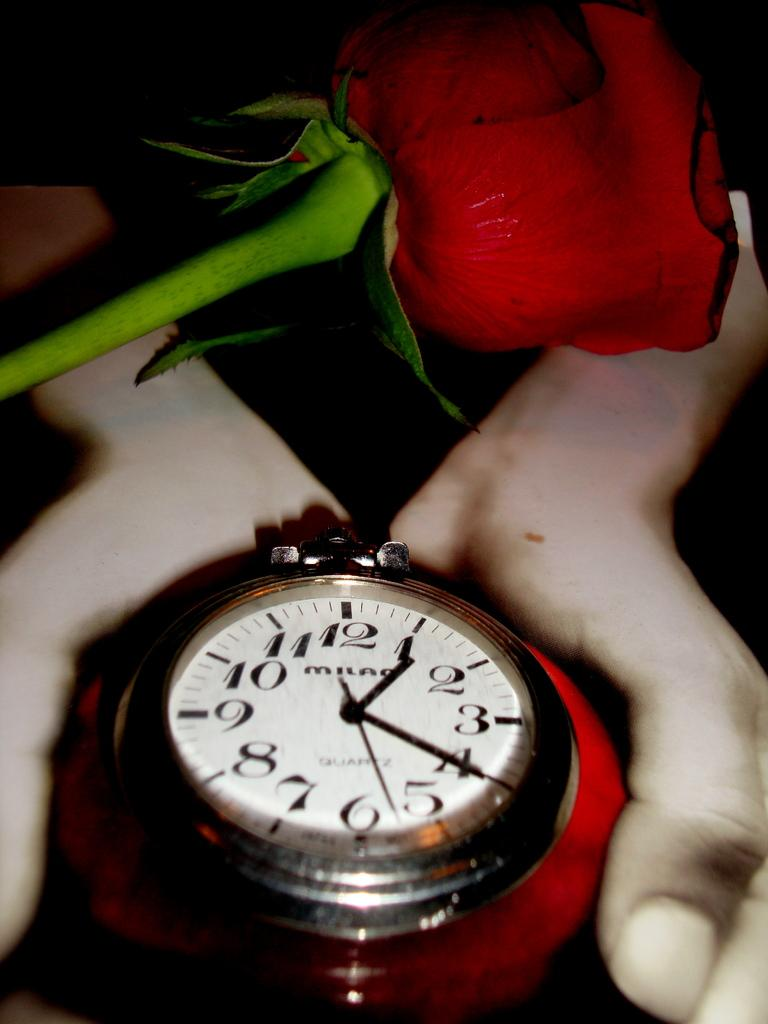<image>
Describe the image concisely. A watch has the word "MILAO" on the face. 